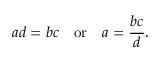<formula> <loc_0><loc_0><loc_500><loc_500>a d = b c \quad o r \quad a = { \frac { b c } { d } } .</formula> 